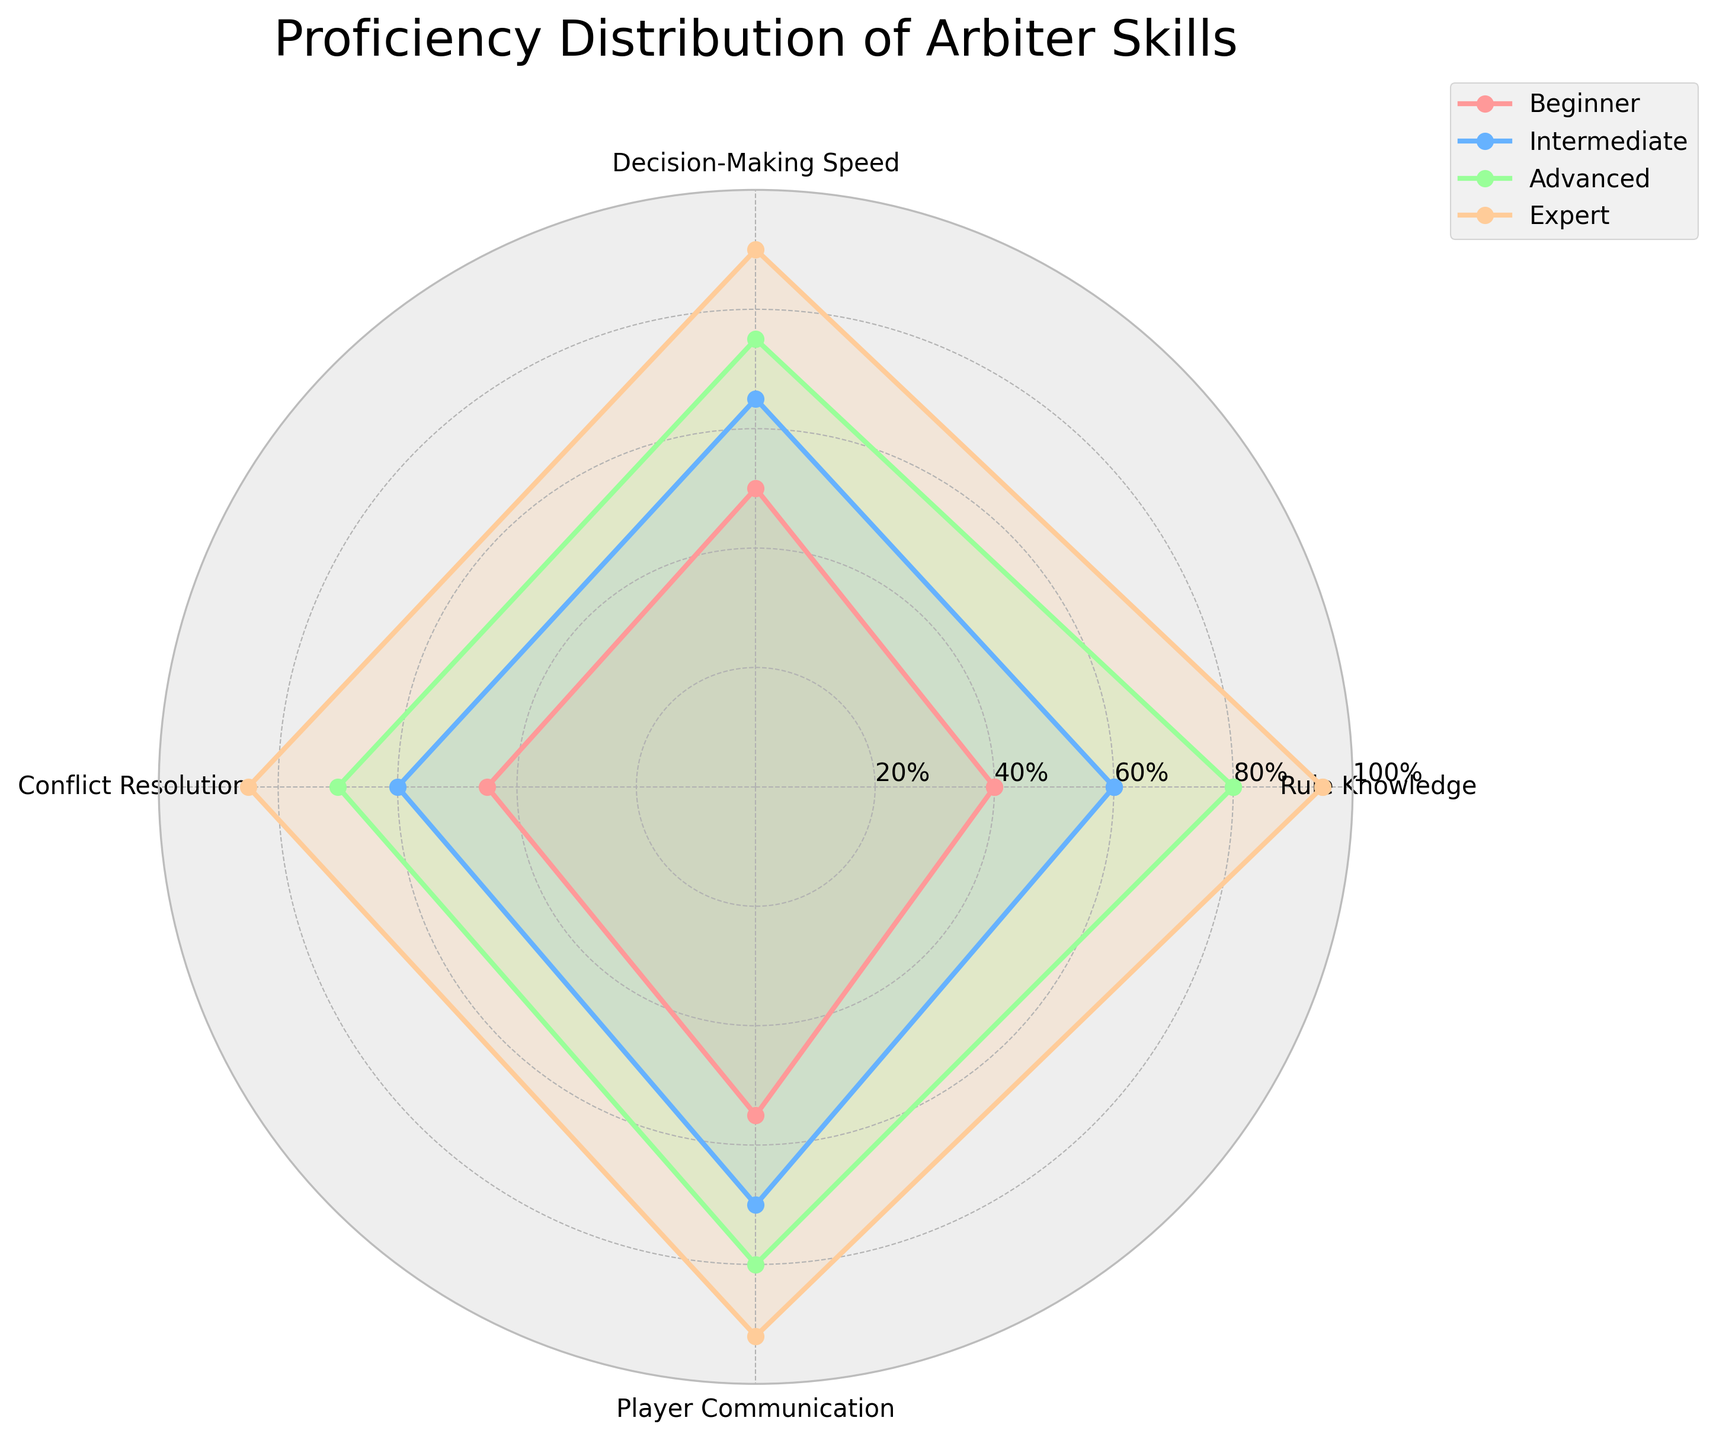What's the title of the figure? The title is displayed prominently at the top of the radar chart.
Answer: Proficiency Distribution of Arbiter Skills What are the different skill levels displayed on the radar chart? The skill levels are indicated by the colors and corresponding labels in the legend.
Answer: Beginner, Intermediate, Advanced, Expert Which skill has the highest proficiency for experts? By looking at the point farthest from the center for the expert skill level, we find the highest proficiency.
Answer: Rule Knowledge What is the difference in decision-making speed proficiency between beginners and experts? First, find the values of decision-making speed for beginners and experts, then subtract the beginner's value from the expert's value.
Answer: 40% Which skill has the smallest proficiency difference between beginners and experts? Calculate the differences for each skill between beginners and experts, then identify the smallest value.
Answer: Conflict Resolution What is the average player communication proficiency across all skill levels? Sum the player communication values for beginners, intermediates, advanced, and experts, then divide by the number of skill levels.
Answer: 74.25% Among the four skills, which one shows the most consistent proficiency across all levels? Compare the range (difference between maximum and minimum) of each skill across all levels and choose the smallest range.
Answer: Player Communication In which skill is the intermediate proficiency level closest to the advanced proficiency level? Calculate the absolute differences between intermediate and advanced levels for each skill, and identify the smallest difference.
Answer: Player Communication How does the overall trend in proficiency for conflict resolution change from beginner to expert? Observe and describe the general increase or decrease in values for conflict resolution from beginner to expert levels on the radar chart.
Answer: Increasing Which skill level represents the widest variability in rule knowledge proficiency? Calculate the range for rule knowledge at each skill level and identify the level with the maximum range.
Answer: Expert 